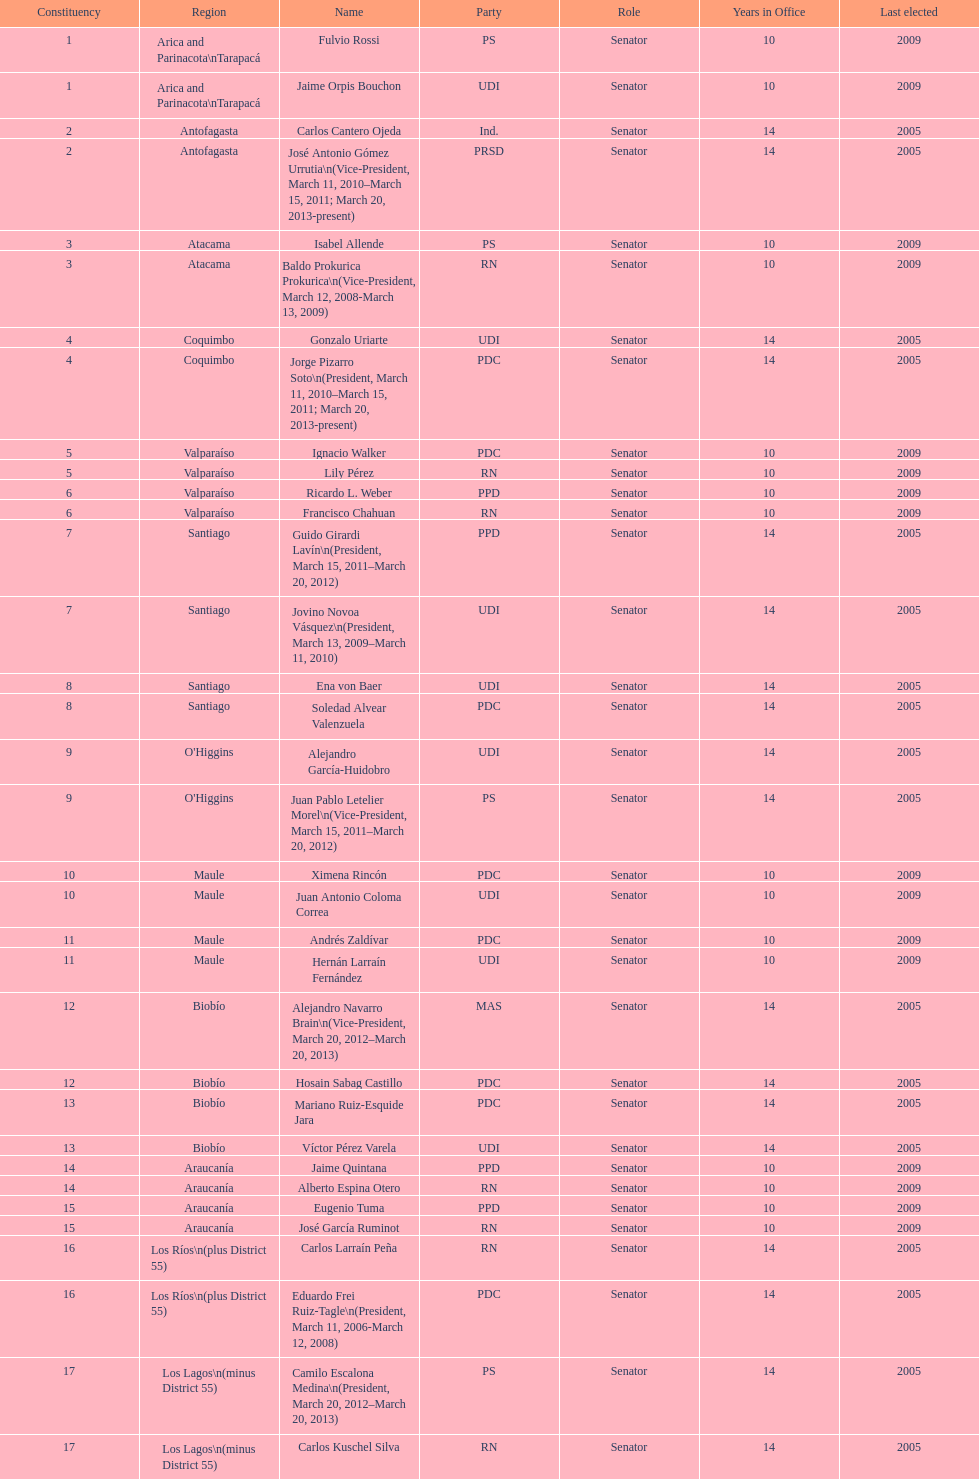How many total consituency are listed in the table? 19. 